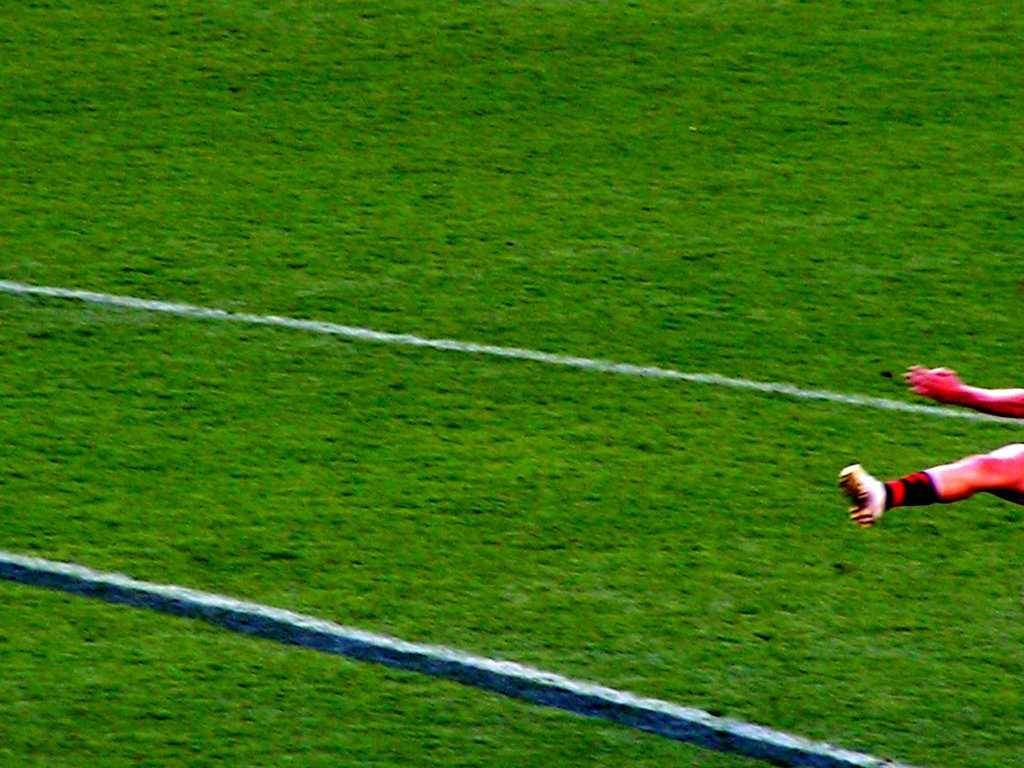What type of surface is visible in the image? There is a ground with grass in the image. Can you describe any body parts visible in the image? Yes, a person's hand and leg are visible on the right side of the image. What type of crack can be seen in the image? There is no crack visible in the image. How does the person in the image control the weather? There is no indication in the image that the person has any control over the weather. 